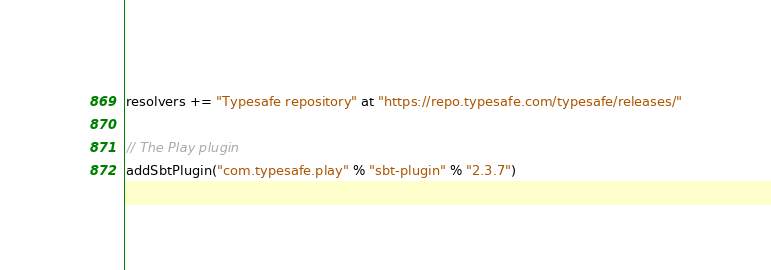Convert code to text. <code><loc_0><loc_0><loc_500><loc_500><_Scala_>resolvers += "Typesafe repository" at "https://repo.typesafe.com/typesafe/releases/"

// The Play plugin
addSbtPlugin("com.typesafe.play" % "sbt-plugin" % "2.3.7")


</code> 